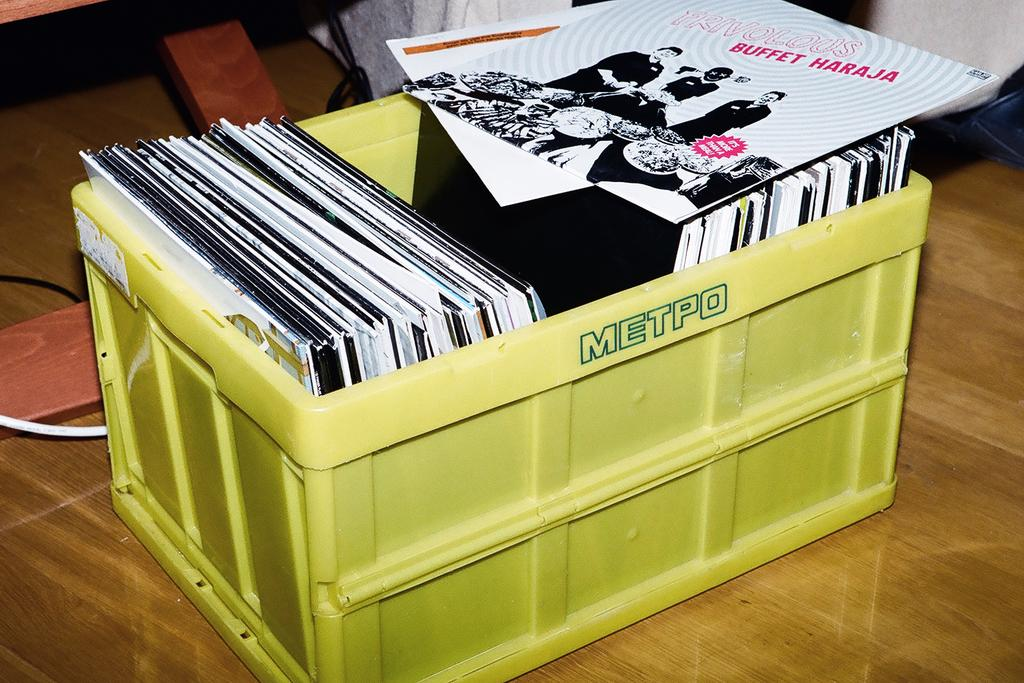<image>
Write a terse but informative summary of the picture. A series of musical albums are inside a yellow box with the word Metpo on the top. 